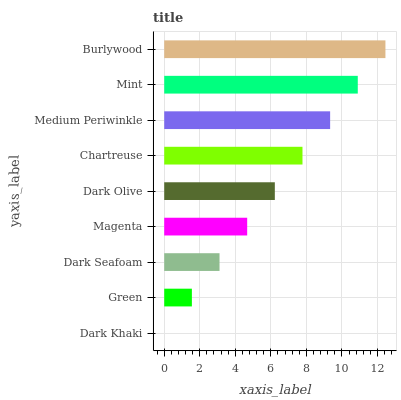Is Dark Khaki the minimum?
Answer yes or no. Yes. Is Burlywood the maximum?
Answer yes or no. Yes. Is Green the minimum?
Answer yes or no. No. Is Green the maximum?
Answer yes or no. No. Is Green greater than Dark Khaki?
Answer yes or no. Yes. Is Dark Khaki less than Green?
Answer yes or no. Yes. Is Dark Khaki greater than Green?
Answer yes or no. No. Is Green less than Dark Khaki?
Answer yes or no. No. Is Dark Olive the high median?
Answer yes or no. Yes. Is Dark Olive the low median?
Answer yes or no. Yes. Is Green the high median?
Answer yes or no. No. Is Mint the low median?
Answer yes or no. No. 